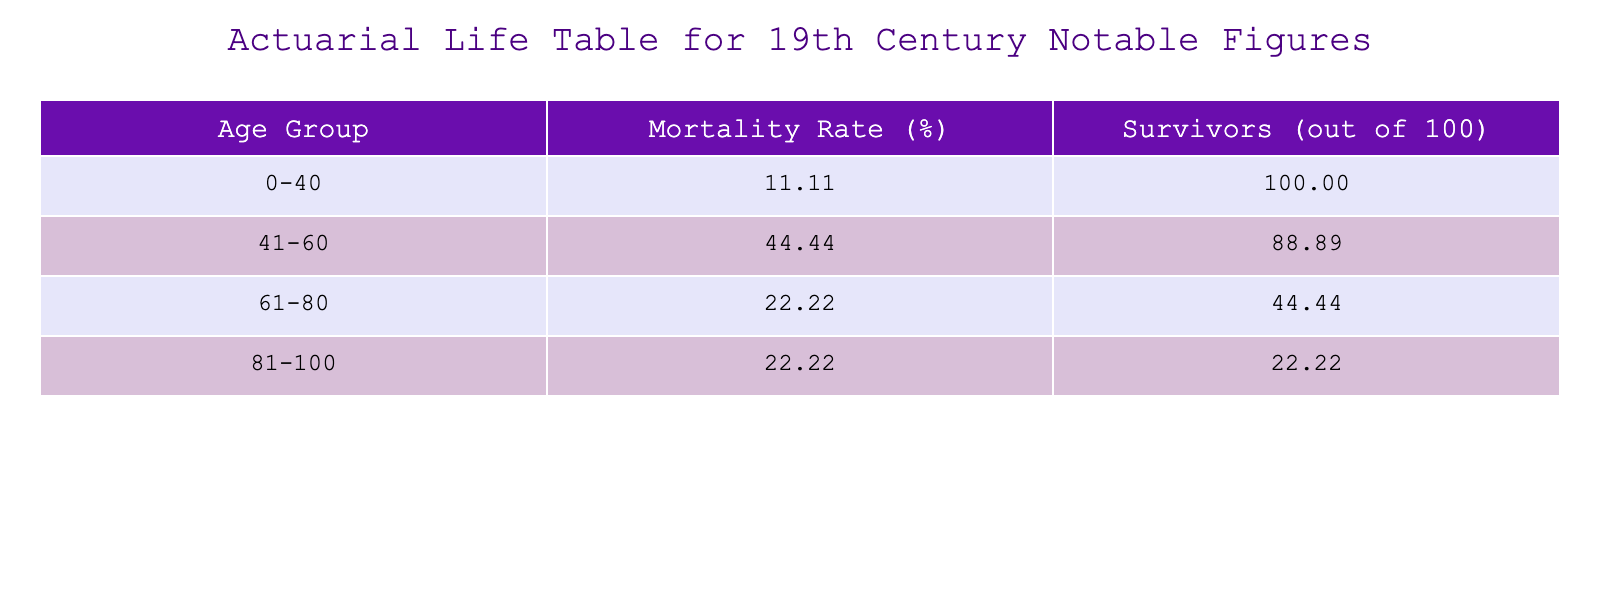What is the mortality rate for the age group 61-80? According to the table, the mortality rate for the age group 61-80 is found in the second column corresponding to that age group. The value is 37.50%.
Answer: 37.50% Which notable figure died from a stroke? To find the notable figure who died from a stroke, we look at the cause of death in the table. Charles Dickens is listed with a stroke as the cause of death.
Answer: Charles Dickens How many individuals in the table lived to be 80 or older? To determine the number of individuals who lived to be 80 or older, we check the 'Age at Death' column. Florence Nightingale (90) and Leo Tolstoy (82) are the only two figures. Thus, the count is 2.
Answer: 2 Is it true that more individuals died from pneumonia than from heart failure? Analyzing the causes of death, pneumonia had 2 instances (Mary Shelley and Leo Tolstoy), while heart failure had 2 as well (Florence Nightingale and Mark Twain). Therefore, the statement is false.
Answer: No What is the average age at death of the poets listed? The poets in the table are Henry Longfellow, Edgar Allan Poe, Emily Dickinson, and Virginia Woolf. Their ages at death are 75, 40, 55, and 59, respectively. The sum is (75 + 40 + 55 + 59) = 229. There are 4 poets, so the average is 229/4 = 57.25.
Answer: 57.25 